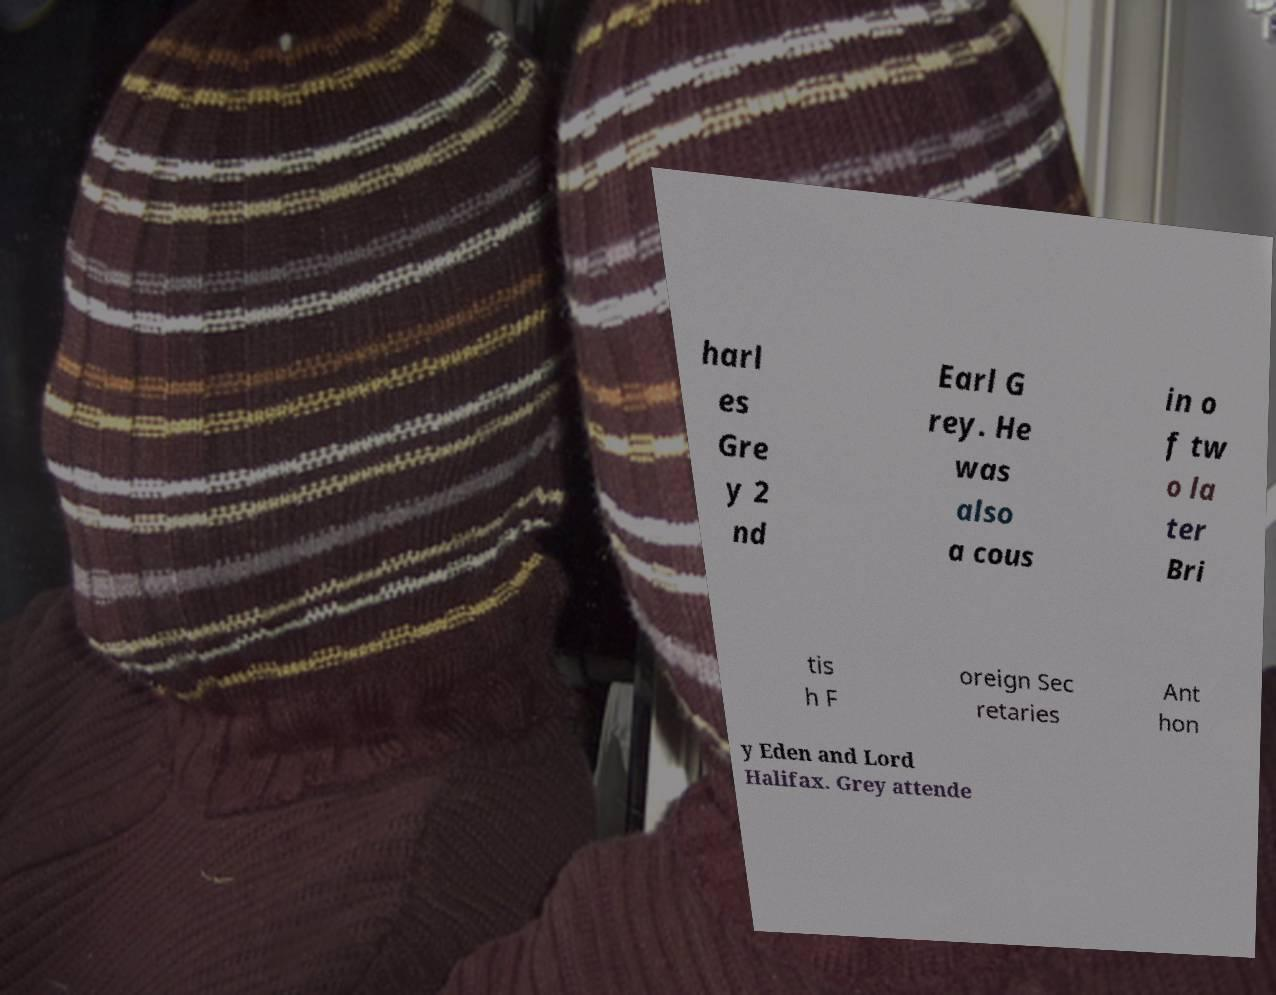I need the written content from this picture converted into text. Can you do that? harl es Gre y 2 nd Earl G rey. He was also a cous in o f tw o la ter Bri tis h F oreign Sec retaries Ant hon y Eden and Lord Halifax. Grey attende 